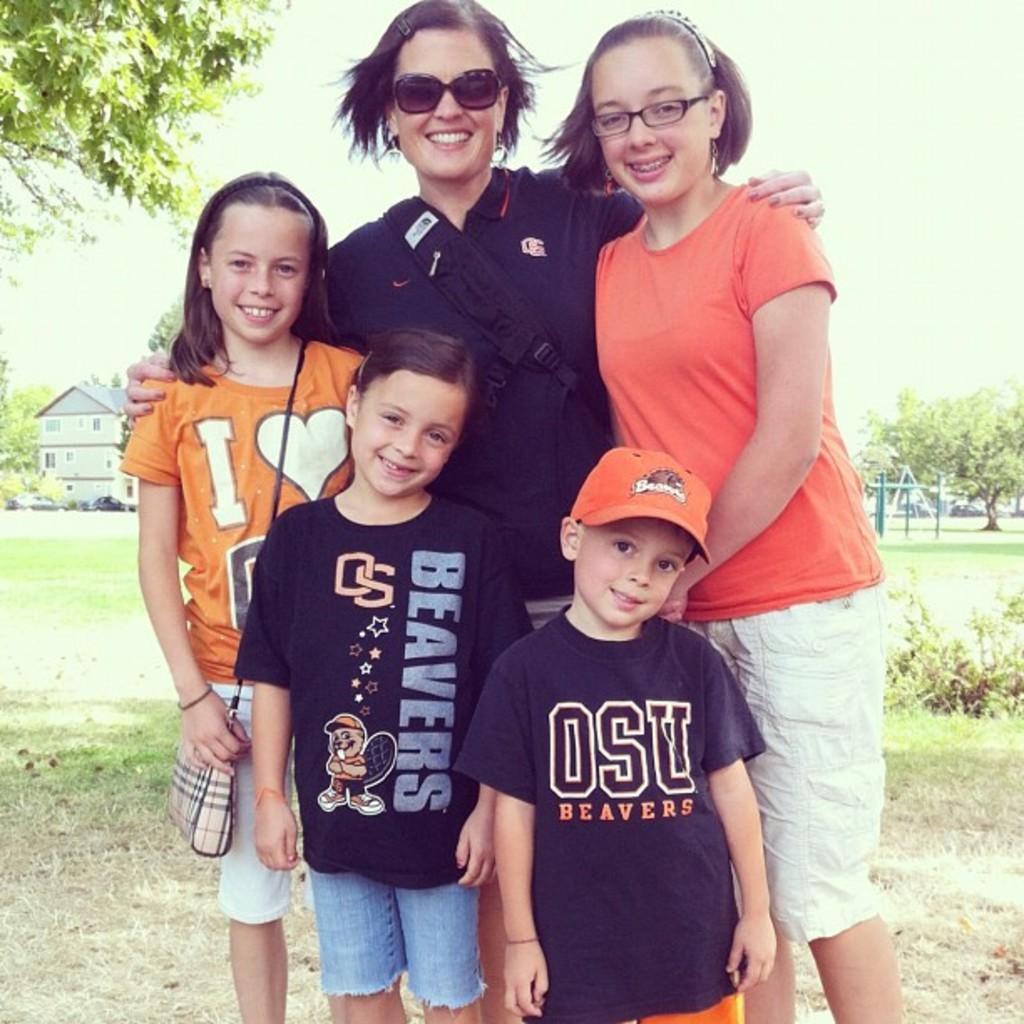Can you describe this image briefly? This image is taken outdoors. At the top of the image there is the sky. In the background there are many trees and plants with leaves, stems and branches. There is a house. A few cars are parked on the ground. There is a ground with grass on it. In the middle of the image a woman and four children are standing on the ground. They are with smiling faces. 